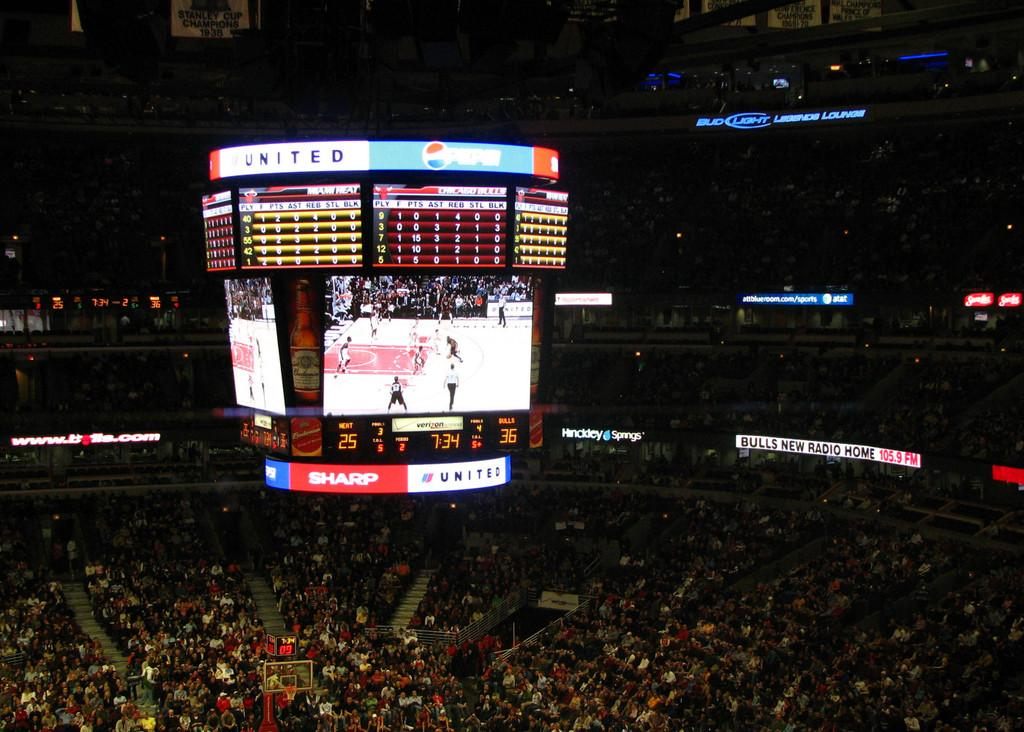Provide a one-sentence caption for the provided image. A video screen of a game in a crowded stadium displays ads for Sharp, United and other companies. 